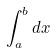Convert formula to latex. <formula><loc_0><loc_0><loc_500><loc_500>\int _ { a } ^ { b } d x</formula> 